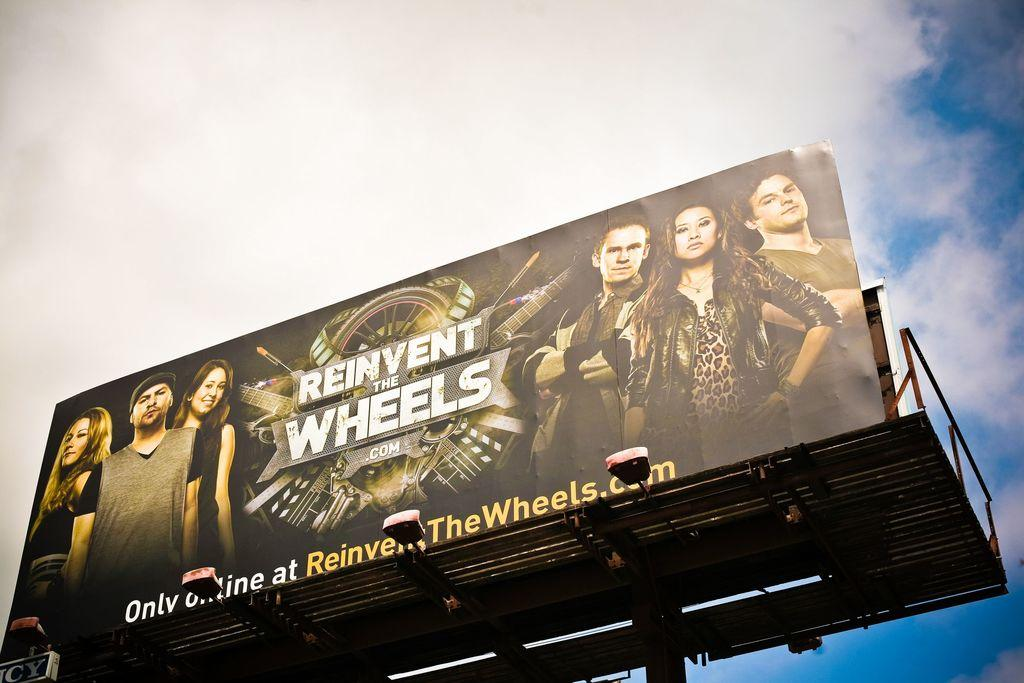Provide a one-sentence caption for the provided image. A logo with reinvent the wheels that is only online. 